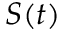Convert formula to latex. <formula><loc_0><loc_0><loc_500><loc_500>S ( t )</formula> 